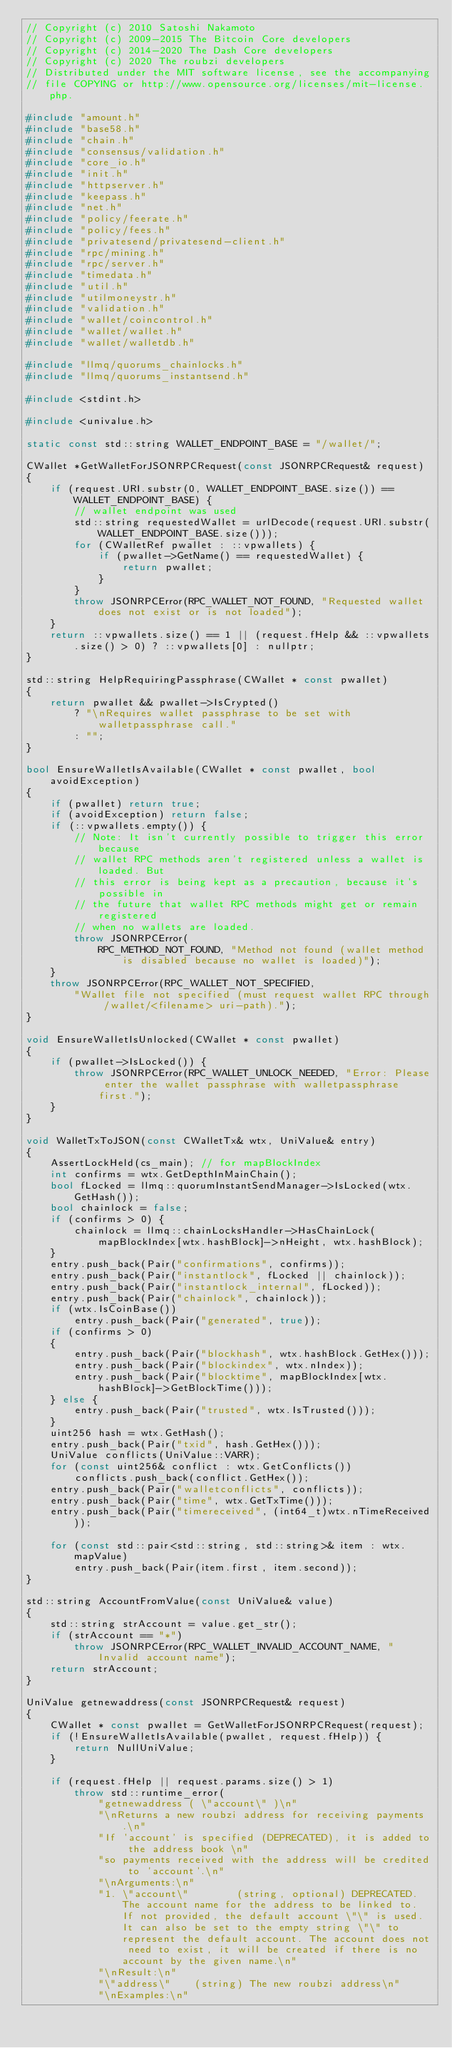Convert code to text. <code><loc_0><loc_0><loc_500><loc_500><_C++_>// Copyright (c) 2010 Satoshi Nakamoto
// Copyright (c) 2009-2015 The Bitcoin Core developers
// Copyright (c) 2014-2020 The Dash Core developers
// Copyright (c) 2020 The roubzi developers
// Distributed under the MIT software license, see the accompanying
// file COPYING or http://www.opensource.org/licenses/mit-license.php.

#include "amount.h"
#include "base58.h"
#include "chain.h"
#include "consensus/validation.h"
#include "core_io.h"
#include "init.h"
#include "httpserver.h"
#include "keepass.h"
#include "net.h"
#include "policy/feerate.h"
#include "policy/fees.h"
#include "privatesend/privatesend-client.h"
#include "rpc/mining.h"
#include "rpc/server.h"
#include "timedata.h"
#include "util.h"
#include "utilmoneystr.h"
#include "validation.h"
#include "wallet/coincontrol.h"
#include "wallet/wallet.h"
#include "wallet/walletdb.h"

#include "llmq/quorums_chainlocks.h"
#include "llmq/quorums_instantsend.h"

#include <stdint.h>

#include <univalue.h>

static const std::string WALLET_ENDPOINT_BASE = "/wallet/";

CWallet *GetWalletForJSONRPCRequest(const JSONRPCRequest& request)
{
    if (request.URI.substr(0, WALLET_ENDPOINT_BASE.size()) == WALLET_ENDPOINT_BASE) {
        // wallet endpoint was used
        std::string requestedWallet = urlDecode(request.URI.substr(WALLET_ENDPOINT_BASE.size()));
        for (CWalletRef pwallet : ::vpwallets) {
            if (pwallet->GetName() == requestedWallet) {
                return pwallet;
            }
        }
        throw JSONRPCError(RPC_WALLET_NOT_FOUND, "Requested wallet does not exist or is not loaded");
    }
    return ::vpwallets.size() == 1 || (request.fHelp && ::vpwallets.size() > 0) ? ::vpwallets[0] : nullptr;
}

std::string HelpRequiringPassphrase(CWallet * const pwallet)
{
    return pwallet && pwallet->IsCrypted()
        ? "\nRequires wallet passphrase to be set with walletpassphrase call."
        : "";
}

bool EnsureWalletIsAvailable(CWallet * const pwallet, bool avoidException)
{
    if (pwallet) return true;
    if (avoidException) return false;
    if (::vpwallets.empty()) {
        // Note: It isn't currently possible to trigger this error because
        // wallet RPC methods aren't registered unless a wallet is loaded. But
        // this error is being kept as a precaution, because it's possible in
        // the future that wallet RPC methods might get or remain registered
        // when no wallets are loaded.
        throw JSONRPCError(
            RPC_METHOD_NOT_FOUND, "Method not found (wallet method is disabled because no wallet is loaded)");
    }
    throw JSONRPCError(RPC_WALLET_NOT_SPECIFIED,
        "Wallet file not specified (must request wallet RPC through /wallet/<filename> uri-path).");
}

void EnsureWalletIsUnlocked(CWallet * const pwallet)
{
    if (pwallet->IsLocked()) {
        throw JSONRPCError(RPC_WALLET_UNLOCK_NEEDED, "Error: Please enter the wallet passphrase with walletpassphrase first.");
    }
}

void WalletTxToJSON(const CWalletTx& wtx, UniValue& entry)
{
    AssertLockHeld(cs_main); // for mapBlockIndex
    int confirms = wtx.GetDepthInMainChain();
    bool fLocked = llmq::quorumInstantSendManager->IsLocked(wtx.GetHash());
    bool chainlock = false;
    if (confirms > 0) {
        chainlock = llmq::chainLocksHandler->HasChainLock(mapBlockIndex[wtx.hashBlock]->nHeight, wtx.hashBlock);
    }
    entry.push_back(Pair("confirmations", confirms));
    entry.push_back(Pair("instantlock", fLocked || chainlock));
    entry.push_back(Pair("instantlock_internal", fLocked));
    entry.push_back(Pair("chainlock", chainlock));
    if (wtx.IsCoinBase())
        entry.push_back(Pair("generated", true));
    if (confirms > 0)
    {
        entry.push_back(Pair("blockhash", wtx.hashBlock.GetHex()));
        entry.push_back(Pair("blockindex", wtx.nIndex));
        entry.push_back(Pair("blocktime", mapBlockIndex[wtx.hashBlock]->GetBlockTime()));
    } else {
        entry.push_back(Pair("trusted", wtx.IsTrusted()));
    }
    uint256 hash = wtx.GetHash();
    entry.push_back(Pair("txid", hash.GetHex()));
    UniValue conflicts(UniValue::VARR);
    for (const uint256& conflict : wtx.GetConflicts())
        conflicts.push_back(conflict.GetHex());
    entry.push_back(Pair("walletconflicts", conflicts));
    entry.push_back(Pair("time", wtx.GetTxTime()));
    entry.push_back(Pair("timereceived", (int64_t)wtx.nTimeReceived));

    for (const std::pair<std::string, std::string>& item : wtx.mapValue)
        entry.push_back(Pair(item.first, item.second));
}

std::string AccountFromValue(const UniValue& value)
{
    std::string strAccount = value.get_str();
    if (strAccount == "*")
        throw JSONRPCError(RPC_WALLET_INVALID_ACCOUNT_NAME, "Invalid account name");
    return strAccount;
}

UniValue getnewaddress(const JSONRPCRequest& request)
{
    CWallet * const pwallet = GetWalletForJSONRPCRequest(request);
    if (!EnsureWalletIsAvailable(pwallet, request.fHelp)) {
        return NullUniValue;
    }

    if (request.fHelp || request.params.size() > 1)
        throw std::runtime_error(
            "getnewaddress ( \"account\" )\n"
            "\nReturns a new roubzi address for receiving payments.\n"
            "If 'account' is specified (DEPRECATED), it is added to the address book \n"
            "so payments received with the address will be credited to 'account'.\n"
            "\nArguments:\n"
            "1. \"account\"        (string, optional) DEPRECATED. The account name for the address to be linked to. If not provided, the default account \"\" is used. It can also be set to the empty string \"\" to represent the default account. The account does not need to exist, it will be created if there is no account by the given name.\n"
            "\nResult:\n"
            "\"address\"    (string) The new roubzi address\n"
            "\nExamples:\n"</code> 